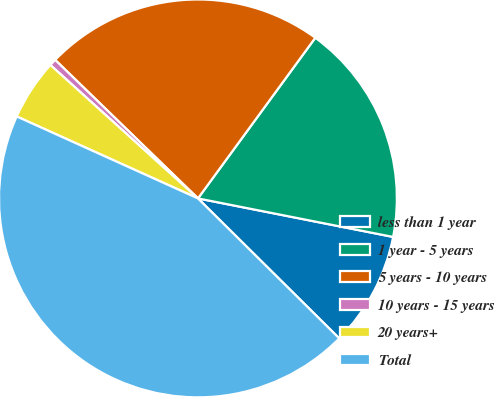Convert chart to OTSL. <chart><loc_0><loc_0><loc_500><loc_500><pie_chart><fcel>less than 1 year<fcel>1 year - 5 years<fcel>5 years - 10 years<fcel>10 years - 15 years<fcel>20 years+<fcel>Total<nl><fcel>9.32%<fcel>18.06%<fcel>22.78%<fcel>0.56%<fcel>4.94%<fcel>44.33%<nl></chart> 